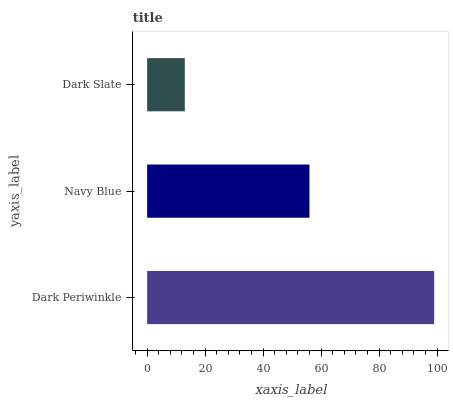Is Dark Slate the minimum?
Answer yes or no. Yes. Is Dark Periwinkle the maximum?
Answer yes or no. Yes. Is Navy Blue the minimum?
Answer yes or no. No. Is Navy Blue the maximum?
Answer yes or no. No. Is Dark Periwinkle greater than Navy Blue?
Answer yes or no. Yes. Is Navy Blue less than Dark Periwinkle?
Answer yes or no. Yes. Is Navy Blue greater than Dark Periwinkle?
Answer yes or no. No. Is Dark Periwinkle less than Navy Blue?
Answer yes or no. No. Is Navy Blue the high median?
Answer yes or no. Yes. Is Navy Blue the low median?
Answer yes or no. Yes. Is Dark Slate the high median?
Answer yes or no. No. Is Dark Periwinkle the low median?
Answer yes or no. No. 